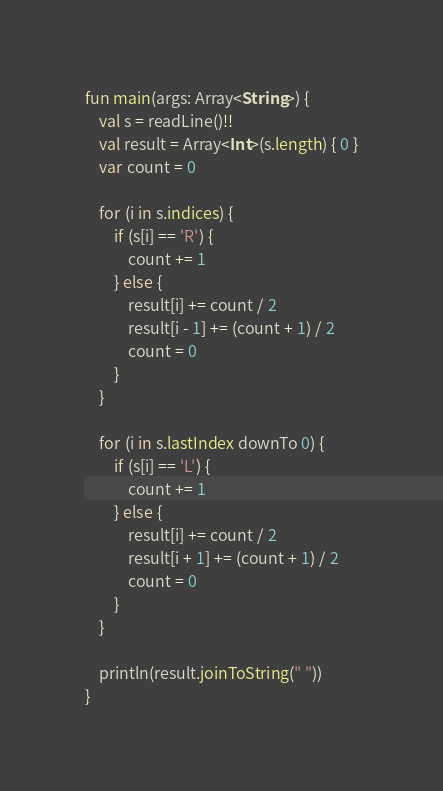<code> <loc_0><loc_0><loc_500><loc_500><_Kotlin_>fun main(args: Array<String>) {
    val s = readLine()!!
    val result = Array<Int>(s.length) { 0 }
    var count = 0

    for (i in s.indices) {
        if (s[i] == 'R') {
            count += 1
        } else {
            result[i] += count / 2
            result[i - 1] += (count + 1) / 2
            count = 0
        }
    }

    for (i in s.lastIndex downTo 0) {
        if (s[i] == 'L') {
            count += 1
        } else {
            result[i] += count / 2
            result[i + 1] += (count + 1) / 2
            count = 0
        }
    }

    println(result.joinToString(" "))
}</code> 